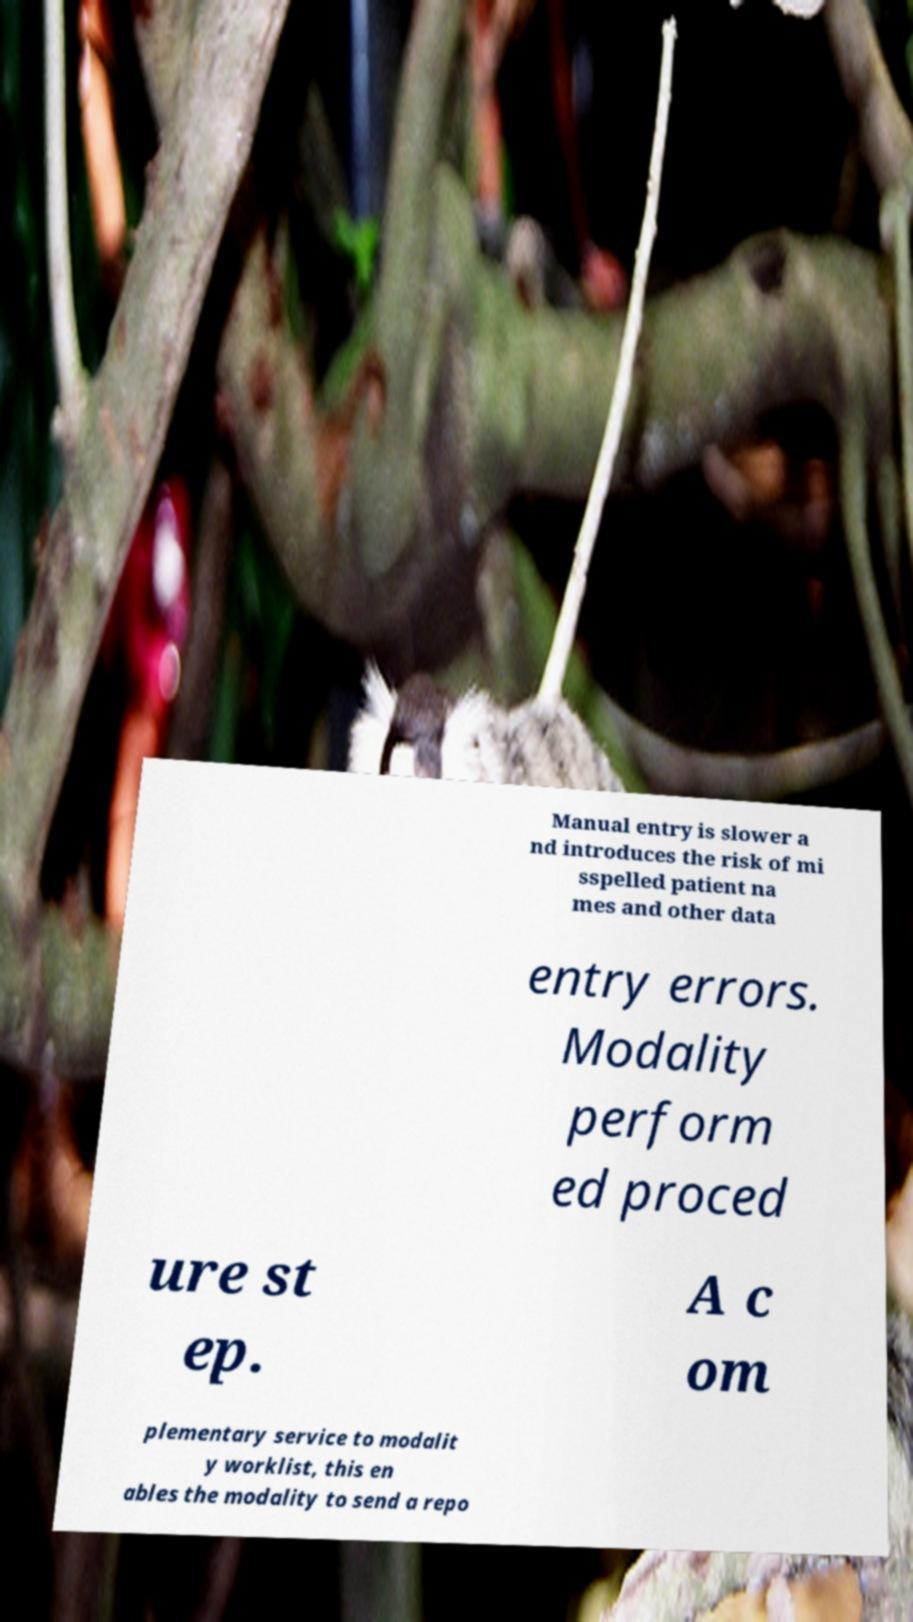I need the written content from this picture converted into text. Can you do that? Manual entry is slower a nd introduces the risk of mi sspelled patient na mes and other data entry errors. Modality perform ed proced ure st ep. A c om plementary service to modalit y worklist, this en ables the modality to send a repo 